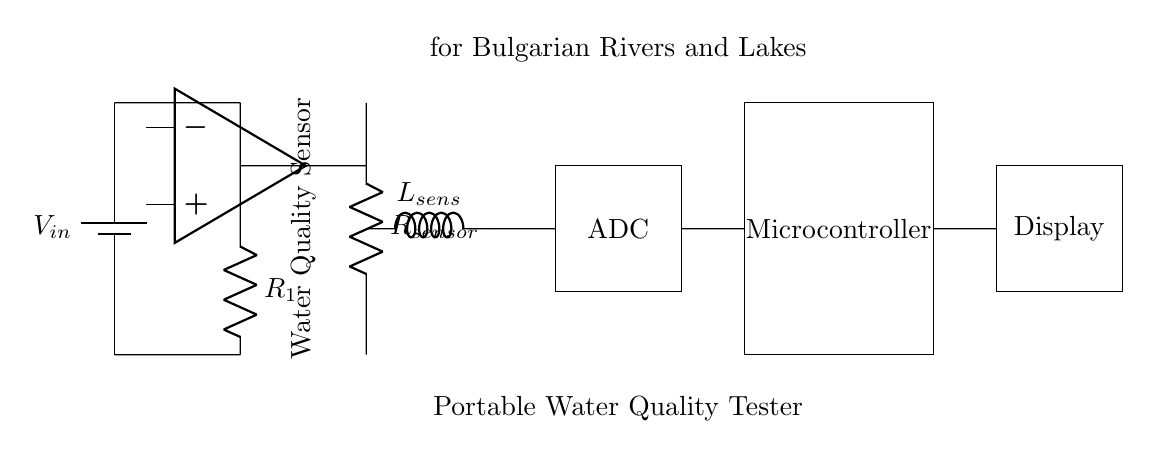What is the purpose of the microcontroller? The microcontroller processes data from the sensor and commands the display output. It is crucial for managing the functionality of the portable water quality tester.
Answer: Processing data What component is used as a power supply? The circuit uses a battery, indicated by the symbol representing it in the circuit diagram. The battery supplies the necessary voltage for the circuit operation.
Answer: Battery What kind of sensor is used in this circuit? The circuit includes a water quality sensor, as labeled in the diagram, which is designed to monitor various parameters of water quality.
Answer: Water Quality Sensor How many main functional blocks are present in the circuit? The circuit consists of four main functional blocks: power supply, sensor block, ADC, and microcontroller. This separation aids in understanding its structure and function.
Answer: Four What is the role of the ADC in this circuit? The ADC converts the analog signals from the sensor into digital signals that the microcontroller can process, which is essential in interpreting sensor data.
Answer: Conversion of signals What does the display show? The display presents the processed water quality data to the user, making it an essential part of the interface for user interaction with the device.
Answer: Water quality data What component connects the sensor to the ADC? A short wire connection is depicted leading from the sensor block directly to the ADC, facilitating signal transmission necessary for data processing.
Answer: Short wire connection 